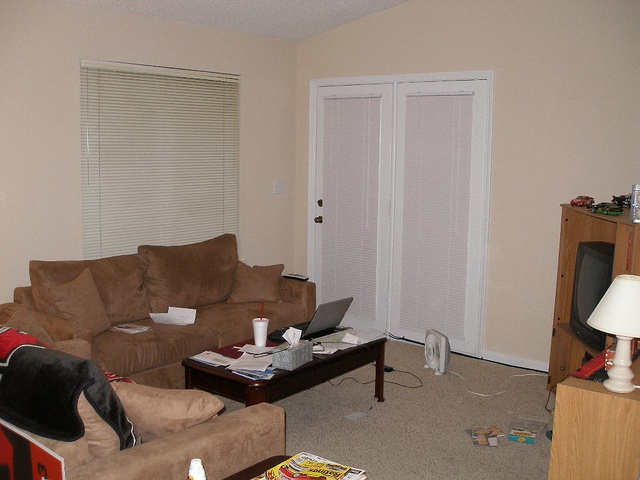Describe the objects in this image and their specific colors. I can see couch in gray, maroon, brown, and darkgray tones, couch in gray and black tones, tv in gray and black tones, book in gray, darkgray, lightgray, and tan tones, and laptop in gray and black tones in this image. 